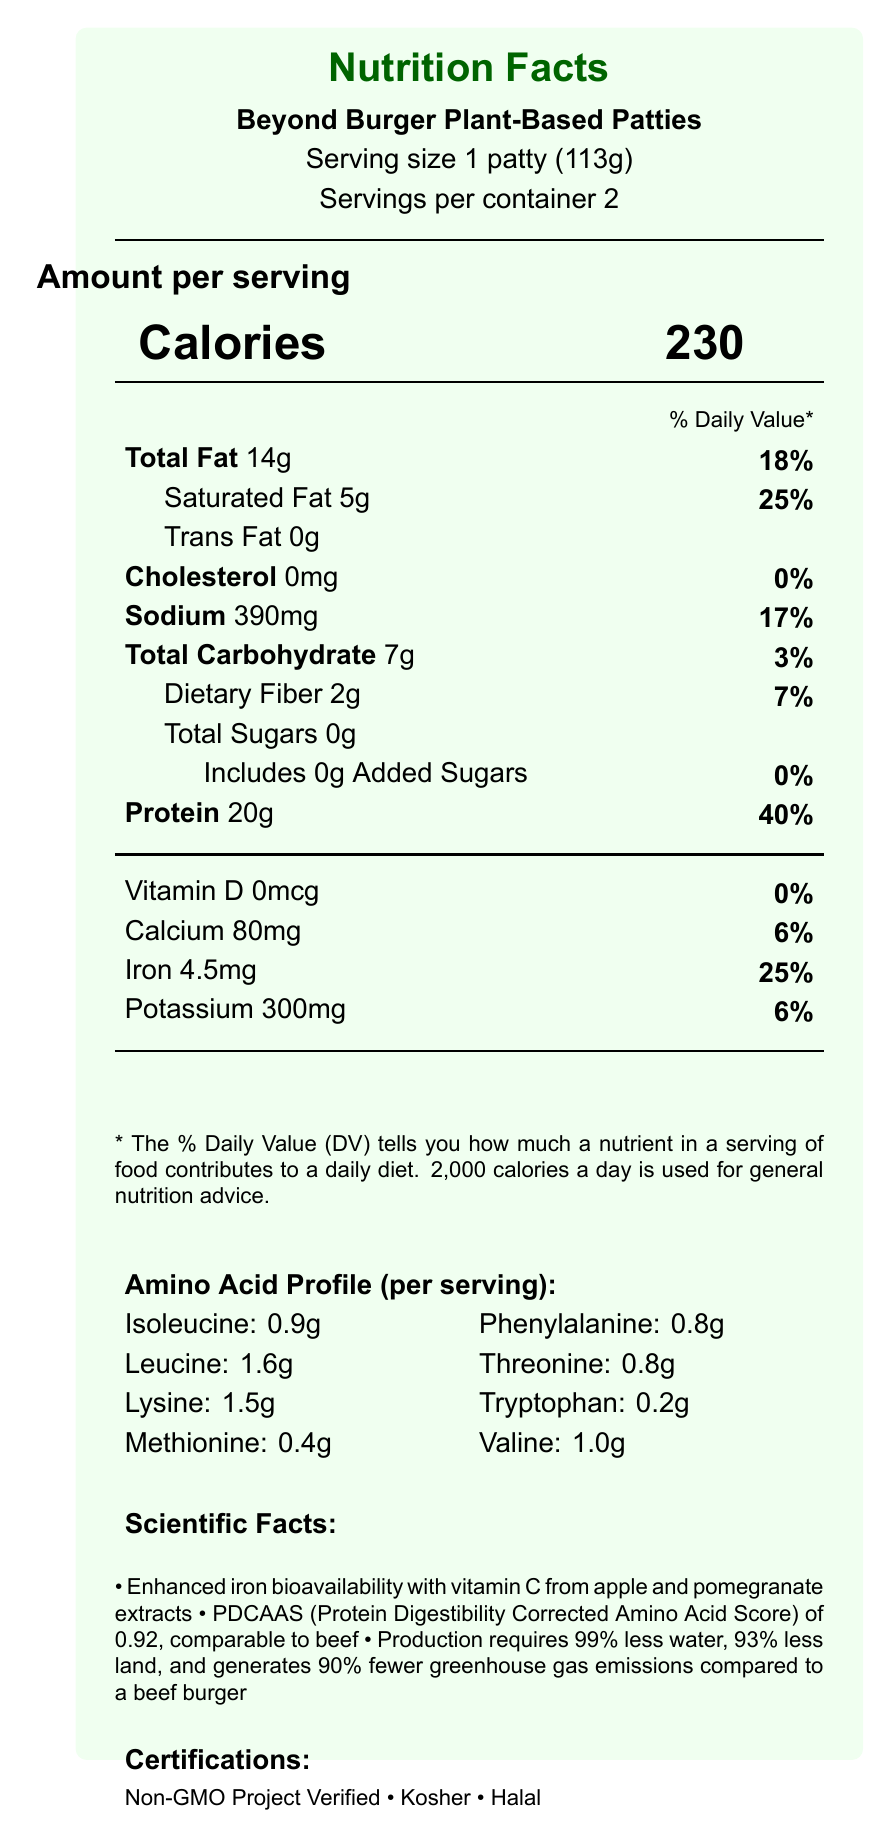what is the serving size of the Beyond Burger Plant-Based Patties? The serving size is explicitly stated as "1 patty (113g)" in the document.
Answer: 1 patty (113g) how much protein is in one serving of the Beyond Burger Plant-Based Patties? The protein content for one serving is clearly listed as 20g.
Answer: 20g what is the percentage of the daily value for iron provided by one serving? The document states that one serving provides 25% of the daily value for iron.
Answer: 25% what is the amount of leucine per serving in the amino acid profile? Leucine is listed with an amount of 1.6g in the amino acid profile.
Answer: 1.6g is the Beyond Burger Plant-Based Patties product Non-GMO Project Verified? The document lists the product as "Non-GMO Project Verified" under certifications.
Answer: Yes which of the following nutrients has the highest daily value percentage per serving? A. Total Fat B. Saturated Fat C. Sodium D. Iron Saturated Fat has the highest daily value percentage at 25%, followed by Iron at 25%, Total Fat at 18%, and Sodium at 17%.
Answer: B how many grams of dietary fiber are there per serving? A. 1g B. 2g C. 3g D. 4g The dietary fiber content per serving is 2g.
Answer: B does this product contain any cholesterol? The document states that the cholesterol content is 0mg, indicating it contains no cholesterol.
Answer: No is the protein quality of the Beyond Burger similar to that of beef? The document states that the PDCAAS (Protein Digestibility Corrected Amino Acid Score) of 0.92 for the Beyond Burger is comparable to beef.
Answer: Yes describe the environmental sustainability benefits of the Beyond Burger Plant-Based Patties. The document lists the sustainability facts directly, stating specific percentages for water, land use, and greenhouse gas emissions, showing the product's benefits over traditional beef burgers.
Answer: The Beyond Burger Plant-Based Patties production requires 99% less water, 93% less land, and generates 90% fewer greenhouse gas emissions compared to a beef burger. what is the vitamin D content per serving? The document states that the vitamin D content per serving is 0mcg, but no additional details are provided on vitamin D sources or its fortification in the product.
Answer: Not enough information 